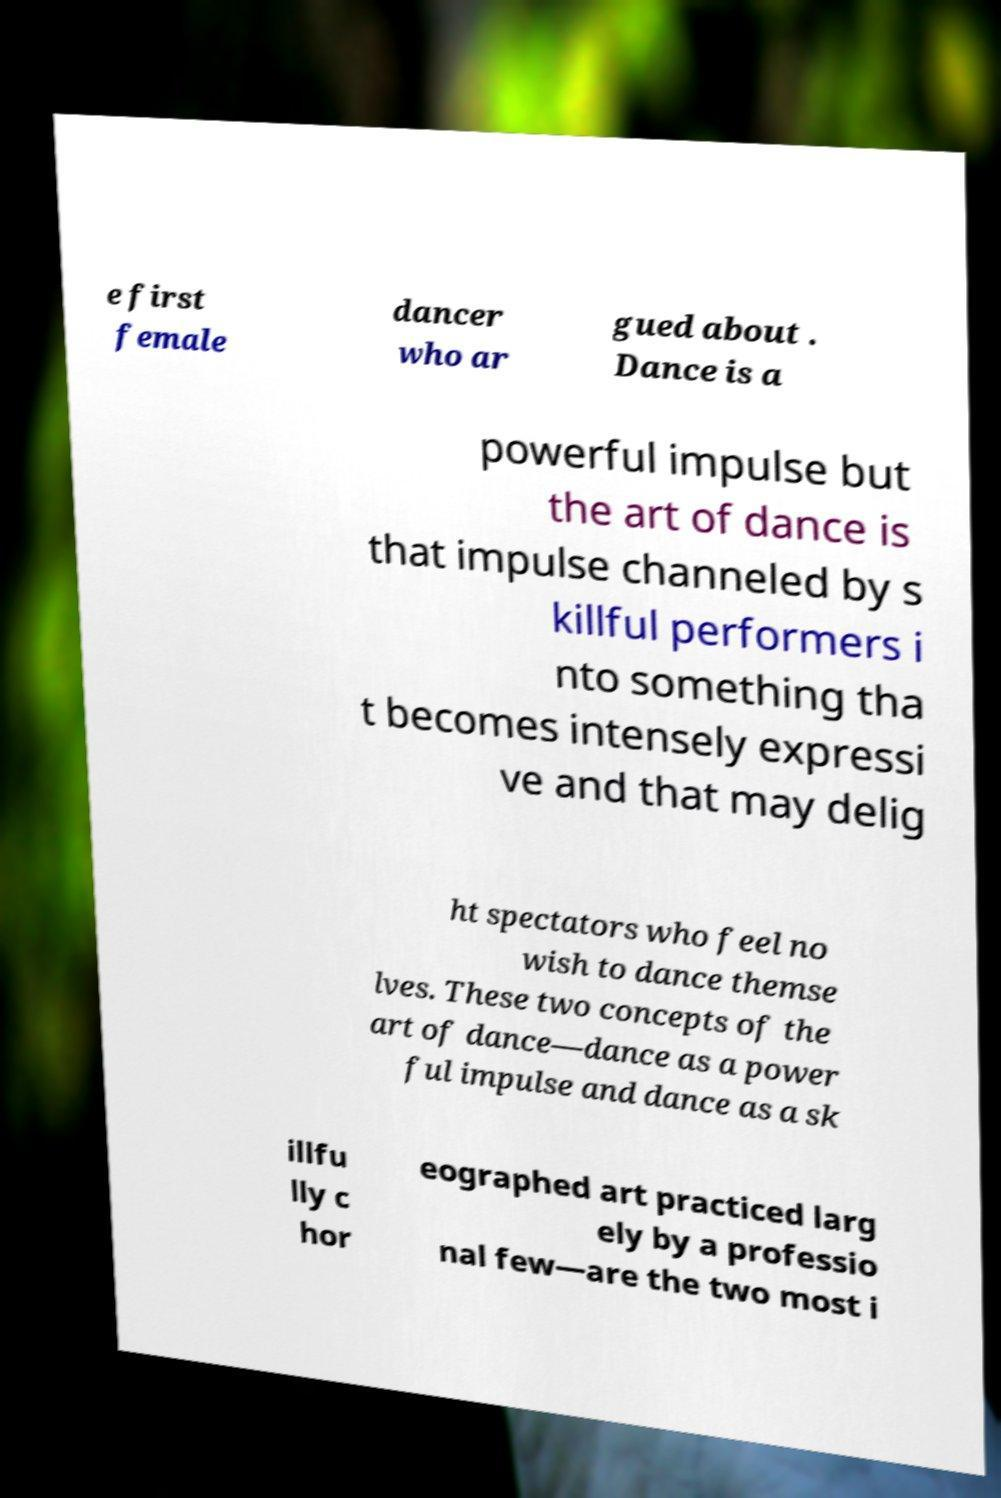Could you assist in decoding the text presented in this image and type it out clearly? e first female dancer who ar gued about . Dance is a powerful impulse but the art of dance is that impulse channeled by s killful performers i nto something tha t becomes intensely expressi ve and that may delig ht spectators who feel no wish to dance themse lves. These two concepts of the art of dance—dance as a power ful impulse and dance as a sk illfu lly c hor eographed art practiced larg ely by a professio nal few—are the two most i 